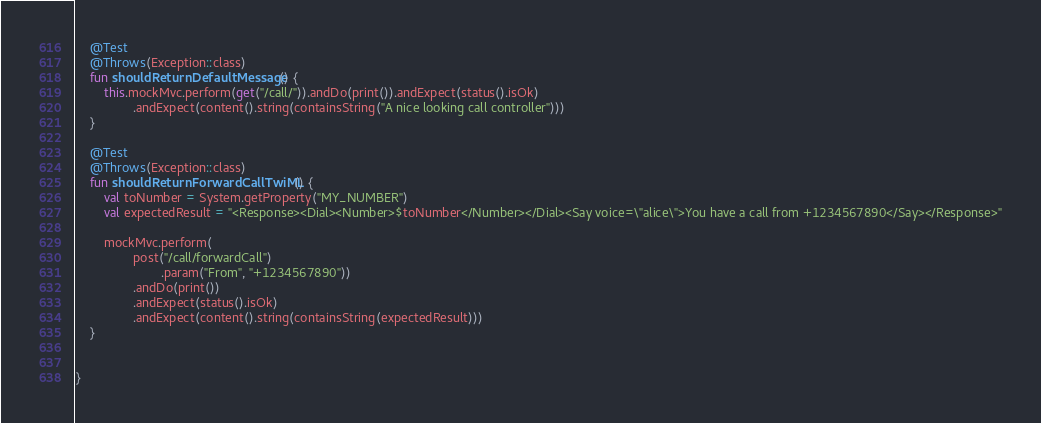<code> <loc_0><loc_0><loc_500><loc_500><_Kotlin_>
    @Test
    @Throws(Exception::class)
    fun shouldReturnDefaultMessage() {
        this.mockMvc.perform(get("/call/")).andDo(print()).andExpect(status().isOk)
                .andExpect(content().string(containsString("A nice looking call controller")))
    }

    @Test
    @Throws(Exception::class)
    fun shouldReturnForwardCallTwiML() {
        val toNumber = System.getProperty("MY_NUMBER")
        val expectedResult = "<Response><Dial><Number>$toNumber</Number></Dial><Say voice=\"alice\">You have a call from +1234567890</Say></Response>"

        mockMvc.perform(
                post("/call/forwardCall")
                        .param("From", "+1234567890"))
                .andDo(print())
                .andExpect(status().isOk)
                .andExpect(content().string(containsString(expectedResult)))
    }


}</code> 